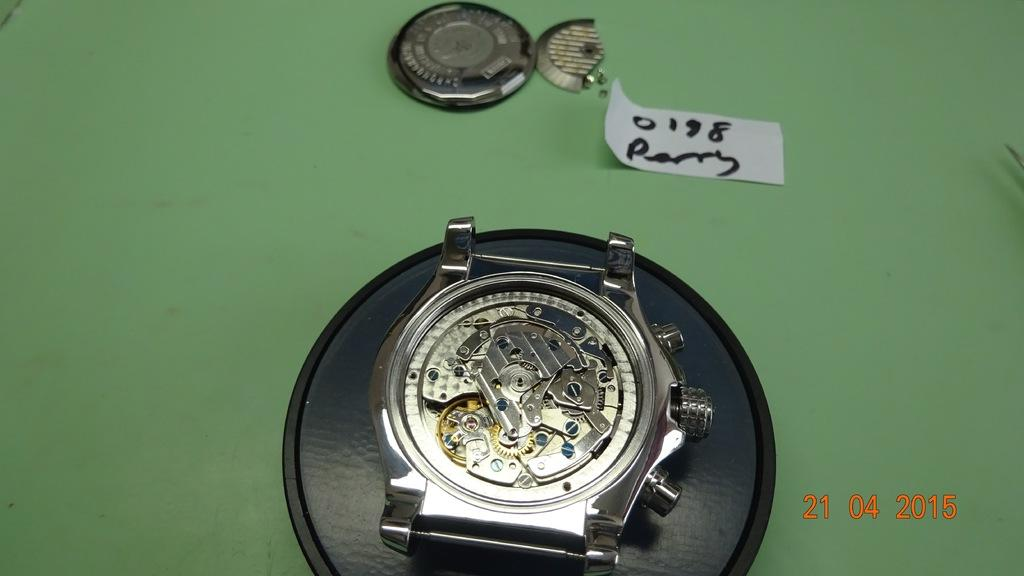<image>
Write a terse but informative summary of the picture. A watch with the back taken off with the date stamp of april 21st 2015/ 